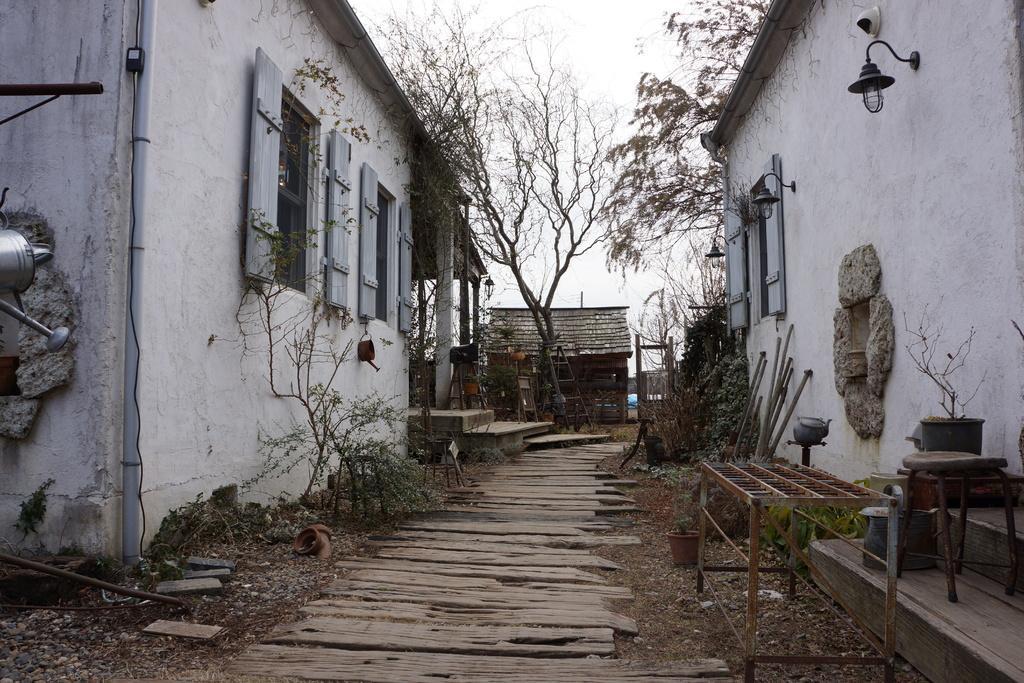Please provide a concise description of this image. In the image there are two houses and there is a wooden path in between those houses and around that path there are some plants and other objects. In the background there is a hut and beside the hut there are few trees. 